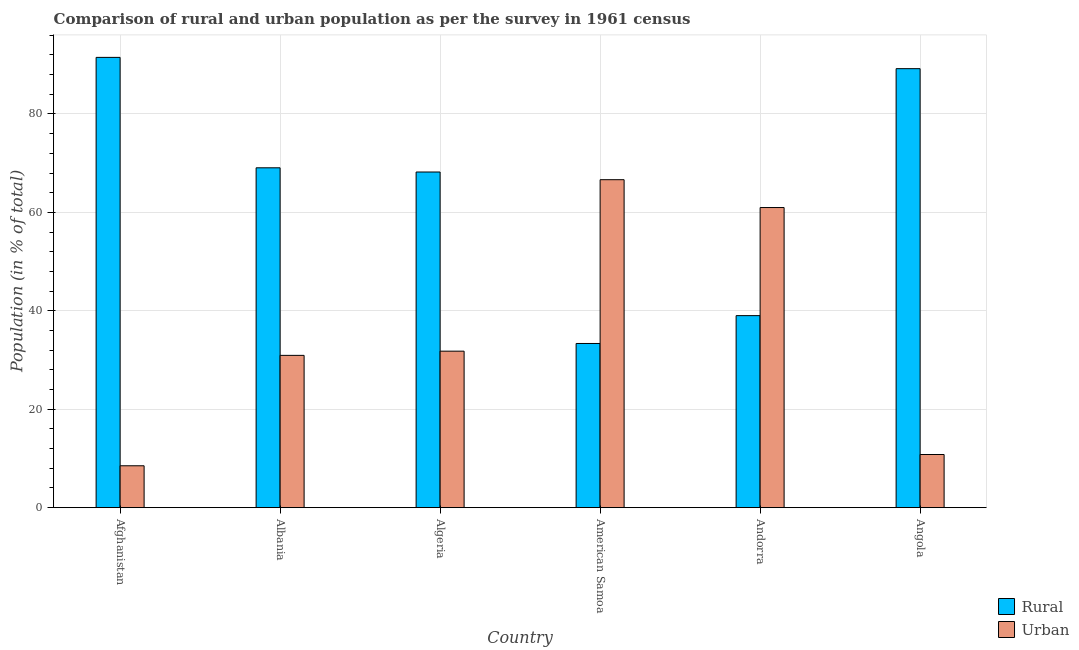How many different coloured bars are there?
Provide a succinct answer. 2. How many groups of bars are there?
Offer a terse response. 6. How many bars are there on the 6th tick from the left?
Your answer should be very brief. 2. How many bars are there on the 1st tick from the right?
Your response must be concise. 2. What is the label of the 1st group of bars from the left?
Make the answer very short. Afghanistan. What is the rural population in Afghanistan?
Ensure brevity in your answer.  91.49. Across all countries, what is the maximum urban population?
Offer a very short reply. 66.64. Across all countries, what is the minimum urban population?
Provide a short and direct response. 8.51. In which country was the rural population maximum?
Your answer should be very brief. Afghanistan. In which country was the urban population minimum?
Keep it short and to the point. Afghanistan. What is the total urban population in the graph?
Keep it short and to the point. 209.67. What is the difference between the rural population in Afghanistan and that in Algeria?
Offer a very short reply. 23.29. What is the difference between the rural population in Algeria and the urban population in Albania?
Provide a short and direct response. 37.26. What is the average urban population per country?
Ensure brevity in your answer.  34.95. What is the difference between the rural population and urban population in Angola?
Your response must be concise. 78.4. What is the ratio of the rural population in Albania to that in Algeria?
Make the answer very short. 1.01. Is the urban population in Algeria less than that in American Samoa?
Your response must be concise. Yes. What is the difference between the highest and the second highest urban population?
Ensure brevity in your answer.  5.66. What is the difference between the highest and the lowest urban population?
Offer a very short reply. 58.13. In how many countries, is the rural population greater than the average rural population taken over all countries?
Keep it short and to the point. 4. Is the sum of the urban population in Algeria and American Samoa greater than the maximum rural population across all countries?
Give a very brief answer. Yes. What does the 1st bar from the left in Andorra represents?
Keep it short and to the point. Rural. What does the 2nd bar from the right in Albania represents?
Offer a very short reply. Rural. How many bars are there?
Provide a short and direct response. 12. What is the difference between two consecutive major ticks on the Y-axis?
Provide a succinct answer. 20. Are the values on the major ticks of Y-axis written in scientific E-notation?
Offer a very short reply. No. Does the graph contain any zero values?
Ensure brevity in your answer.  No. Where does the legend appear in the graph?
Your answer should be compact. Bottom right. How many legend labels are there?
Keep it short and to the point. 2. How are the legend labels stacked?
Provide a succinct answer. Vertical. What is the title of the graph?
Make the answer very short. Comparison of rural and urban population as per the survey in 1961 census. Does "Education" appear as one of the legend labels in the graph?
Offer a terse response. No. What is the label or title of the Y-axis?
Provide a short and direct response. Population (in % of total). What is the Population (in % of total) of Rural in Afghanistan?
Provide a short and direct response. 91.49. What is the Population (in % of total) of Urban in Afghanistan?
Your answer should be very brief. 8.51. What is the Population (in % of total) of Rural in Albania?
Make the answer very short. 69.06. What is the Population (in % of total) of Urban in Albania?
Offer a terse response. 30.94. What is the Population (in % of total) of Rural in Algeria?
Keep it short and to the point. 68.2. What is the Population (in % of total) in Urban in Algeria?
Provide a short and direct response. 31.8. What is the Population (in % of total) in Rural in American Samoa?
Offer a very short reply. 33.36. What is the Population (in % of total) in Urban in American Samoa?
Provide a short and direct response. 66.64. What is the Population (in % of total) in Rural in Andorra?
Your answer should be compact. 39.02. What is the Population (in % of total) of Urban in Andorra?
Make the answer very short. 60.98. What is the Population (in % of total) in Rural in Angola?
Keep it short and to the point. 89.2. What is the Population (in % of total) in Urban in Angola?
Offer a very short reply. 10.8. Across all countries, what is the maximum Population (in % of total) of Rural?
Your response must be concise. 91.49. Across all countries, what is the maximum Population (in % of total) of Urban?
Make the answer very short. 66.64. Across all countries, what is the minimum Population (in % of total) of Rural?
Your response must be concise. 33.36. Across all countries, what is the minimum Population (in % of total) in Urban?
Offer a very short reply. 8.51. What is the total Population (in % of total) of Rural in the graph?
Your answer should be very brief. 390.33. What is the total Population (in % of total) in Urban in the graph?
Offer a terse response. 209.67. What is the difference between the Population (in % of total) in Rural in Afghanistan and that in Albania?
Provide a succinct answer. 22.43. What is the difference between the Population (in % of total) in Urban in Afghanistan and that in Albania?
Your response must be concise. -22.43. What is the difference between the Population (in % of total) of Rural in Afghanistan and that in Algeria?
Provide a short and direct response. 23.29. What is the difference between the Population (in % of total) of Urban in Afghanistan and that in Algeria?
Offer a terse response. -23.29. What is the difference between the Population (in % of total) in Rural in Afghanistan and that in American Samoa?
Provide a short and direct response. 58.13. What is the difference between the Population (in % of total) of Urban in Afghanistan and that in American Samoa?
Your answer should be compact. -58.13. What is the difference between the Population (in % of total) of Rural in Afghanistan and that in Andorra?
Your answer should be compact. 52.48. What is the difference between the Population (in % of total) in Urban in Afghanistan and that in Andorra?
Provide a short and direct response. -52.48. What is the difference between the Population (in % of total) in Rural in Afghanistan and that in Angola?
Provide a short and direct response. 2.29. What is the difference between the Population (in % of total) in Urban in Afghanistan and that in Angola?
Your response must be concise. -2.29. What is the difference between the Population (in % of total) in Rural in Albania and that in Algeria?
Provide a short and direct response. 0.85. What is the difference between the Population (in % of total) in Urban in Albania and that in Algeria?
Give a very brief answer. -0.85. What is the difference between the Population (in % of total) of Rural in Albania and that in American Samoa?
Your answer should be compact. 35.7. What is the difference between the Population (in % of total) of Urban in Albania and that in American Samoa?
Provide a short and direct response. -35.7. What is the difference between the Population (in % of total) of Rural in Albania and that in Andorra?
Your answer should be very brief. 30.04. What is the difference between the Population (in % of total) in Urban in Albania and that in Andorra?
Your response must be concise. -30.04. What is the difference between the Population (in % of total) of Rural in Albania and that in Angola?
Make the answer very short. -20.14. What is the difference between the Population (in % of total) in Urban in Albania and that in Angola?
Keep it short and to the point. 20.14. What is the difference between the Population (in % of total) of Rural in Algeria and that in American Samoa?
Give a very brief answer. 34.84. What is the difference between the Population (in % of total) in Urban in Algeria and that in American Samoa?
Give a very brief answer. -34.84. What is the difference between the Population (in % of total) in Rural in Algeria and that in Andorra?
Keep it short and to the point. 29.19. What is the difference between the Population (in % of total) in Urban in Algeria and that in Andorra?
Ensure brevity in your answer.  -29.19. What is the difference between the Population (in % of total) in Rural in Algeria and that in Angola?
Keep it short and to the point. -21. What is the difference between the Population (in % of total) in Urban in Algeria and that in Angola?
Your response must be concise. 21. What is the difference between the Population (in % of total) in Rural in American Samoa and that in Andorra?
Make the answer very short. -5.66. What is the difference between the Population (in % of total) in Urban in American Samoa and that in Andorra?
Offer a terse response. 5.66. What is the difference between the Population (in % of total) in Rural in American Samoa and that in Angola?
Your answer should be very brief. -55.84. What is the difference between the Population (in % of total) of Urban in American Samoa and that in Angola?
Provide a succinct answer. 55.84. What is the difference between the Population (in % of total) in Rural in Andorra and that in Angola?
Give a very brief answer. -50.19. What is the difference between the Population (in % of total) in Urban in Andorra and that in Angola?
Make the answer very short. 50.19. What is the difference between the Population (in % of total) in Rural in Afghanistan and the Population (in % of total) in Urban in Albania?
Your answer should be very brief. 60.55. What is the difference between the Population (in % of total) in Rural in Afghanistan and the Population (in % of total) in Urban in Algeria?
Ensure brevity in your answer.  59.7. What is the difference between the Population (in % of total) in Rural in Afghanistan and the Population (in % of total) in Urban in American Samoa?
Provide a short and direct response. 24.85. What is the difference between the Population (in % of total) of Rural in Afghanistan and the Population (in % of total) of Urban in Andorra?
Keep it short and to the point. 30.51. What is the difference between the Population (in % of total) of Rural in Afghanistan and the Population (in % of total) of Urban in Angola?
Make the answer very short. 80.69. What is the difference between the Population (in % of total) of Rural in Albania and the Population (in % of total) of Urban in Algeria?
Ensure brevity in your answer.  37.26. What is the difference between the Population (in % of total) in Rural in Albania and the Population (in % of total) in Urban in American Samoa?
Provide a succinct answer. 2.42. What is the difference between the Population (in % of total) of Rural in Albania and the Population (in % of total) of Urban in Andorra?
Offer a very short reply. 8.07. What is the difference between the Population (in % of total) of Rural in Albania and the Population (in % of total) of Urban in Angola?
Give a very brief answer. 58.26. What is the difference between the Population (in % of total) in Rural in Algeria and the Population (in % of total) in Urban in American Samoa?
Make the answer very short. 1.56. What is the difference between the Population (in % of total) in Rural in Algeria and the Population (in % of total) in Urban in Andorra?
Keep it short and to the point. 7.22. What is the difference between the Population (in % of total) of Rural in Algeria and the Population (in % of total) of Urban in Angola?
Offer a terse response. 57.41. What is the difference between the Population (in % of total) in Rural in American Samoa and the Population (in % of total) in Urban in Andorra?
Provide a short and direct response. -27.62. What is the difference between the Population (in % of total) of Rural in American Samoa and the Population (in % of total) of Urban in Angola?
Keep it short and to the point. 22.56. What is the difference between the Population (in % of total) in Rural in Andorra and the Population (in % of total) in Urban in Angola?
Keep it short and to the point. 28.22. What is the average Population (in % of total) of Rural per country?
Keep it short and to the point. 65.06. What is the average Population (in % of total) in Urban per country?
Your response must be concise. 34.95. What is the difference between the Population (in % of total) of Rural and Population (in % of total) of Urban in Afghanistan?
Offer a terse response. 82.98. What is the difference between the Population (in % of total) in Rural and Population (in % of total) in Urban in Albania?
Ensure brevity in your answer.  38.11. What is the difference between the Population (in % of total) of Rural and Population (in % of total) of Urban in Algeria?
Provide a short and direct response. 36.41. What is the difference between the Population (in % of total) in Rural and Population (in % of total) in Urban in American Samoa?
Give a very brief answer. -33.28. What is the difference between the Population (in % of total) of Rural and Population (in % of total) of Urban in Andorra?
Offer a very short reply. -21.97. What is the difference between the Population (in % of total) of Rural and Population (in % of total) of Urban in Angola?
Your answer should be compact. 78.4. What is the ratio of the Population (in % of total) in Rural in Afghanistan to that in Albania?
Your answer should be very brief. 1.32. What is the ratio of the Population (in % of total) in Urban in Afghanistan to that in Albania?
Make the answer very short. 0.28. What is the ratio of the Population (in % of total) of Rural in Afghanistan to that in Algeria?
Provide a short and direct response. 1.34. What is the ratio of the Population (in % of total) of Urban in Afghanistan to that in Algeria?
Provide a short and direct response. 0.27. What is the ratio of the Population (in % of total) in Rural in Afghanistan to that in American Samoa?
Provide a short and direct response. 2.74. What is the ratio of the Population (in % of total) in Urban in Afghanistan to that in American Samoa?
Offer a very short reply. 0.13. What is the ratio of the Population (in % of total) in Rural in Afghanistan to that in Andorra?
Your response must be concise. 2.34. What is the ratio of the Population (in % of total) in Urban in Afghanistan to that in Andorra?
Offer a very short reply. 0.14. What is the ratio of the Population (in % of total) in Rural in Afghanistan to that in Angola?
Offer a terse response. 1.03. What is the ratio of the Population (in % of total) of Urban in Afghanistan to that in Angola?
Give a very brief answer. 0.79. What is the ratio of the Population (in % of total) in Rural in Albania to that in Algeria?
Your response must be concise. 1.01. What is the ratio of the Population (in % of total) in Urban in Albania to that in Algeria?
Provide a short and direct response. 0.97. What is the ratio of the Population (in % of total) in Rural in Albania to that in American Samoa?
Keep it short and to the point. 2.07. What is the ratio of the Population (in % of total) of Urban in Albania to that in American Samoa?
Ensure brevity in your answer.  0.46. What is the ratio of the Population (in % of total) of Rural in Albania to that in Andorra?
Your answer should be very brief. 1.77. What is the ratio of the Population (in % of total) of Urban in Albania to that in Andorra?
Keep it short and to the point. 0.51. What is the ratio of the Population (in % of total) in Rural in Albania to that in Angola?
Provide a short and direct response. 0.77. What is the ratio of the Population (in % of total) in Urban in Albania to that in Angola?
Keep it short and to the point. 2.87. What is the ratio of the Population (in % of total) in Rural in Algeria to that in American Samoa?
Keep it short and to the point. 2.04. What is the ratio of the Population (in % of total) of Urban in Algeria to that in American Samoa?
Give a very brief answer. 0.48. What is the ratio of the Population (in % of total) in Rural in Algeria to that in Andorra?
Offer a very short reply. 1.75. What is the ratio of the Population (in % of total) in Urban in Algeria to that in Andorra?
Ensure brevity in your answer.  0.52. What is the ratio of the Population (in % of total) of Rural in Algeria to that in Angola?
Provide a succinct answer. 0.76. What is the ratio of the Population (in % of total) of Urban in Algeria to that in Angola?
Your answer should be very brief. 2.94. What is the ratio of the Population (in % of total) of Rural in American Samoa to that in Andorra?
Provide a succinct answer. 0.85. What is the ratio of the Population (in % of total) in Urban in American Samoa to that in Andorra?
Ensure brevity in your answer.  1.09. What is the ratio of the Population (in % of total) in Rural in American Samoa to that in Angola?
Your answer should be compact. 0.37. What is the ratio of the Population (in % of total) of Urban in American Samoa to that in Angola?
Your answer should be very brief. 6.17. What is the ratio of the Population (in % of total) of Rural in Andorra to that in Angola?
Keep it short and to the point. 0.44. What is the ratio of the Population (in % of total) of Urban in Andorra to that in Angola?
Offer a terse response. 5.65. What is the difference between the highest and the second highest Population (in % of total) of Rural?
Provide a short and direct response. 2.29. What is the difference between the highest and the second highest Population (in % of total) in Urban?
Make the answer very short. 5.66. What is the difference between the highest and the lowest Population (in % of total) of Rural?
Make the answer very short. 58.13. What is the difference between the highest and the lowest Population (in % of total) in Urban?
Make the answer very short. 58.13. 